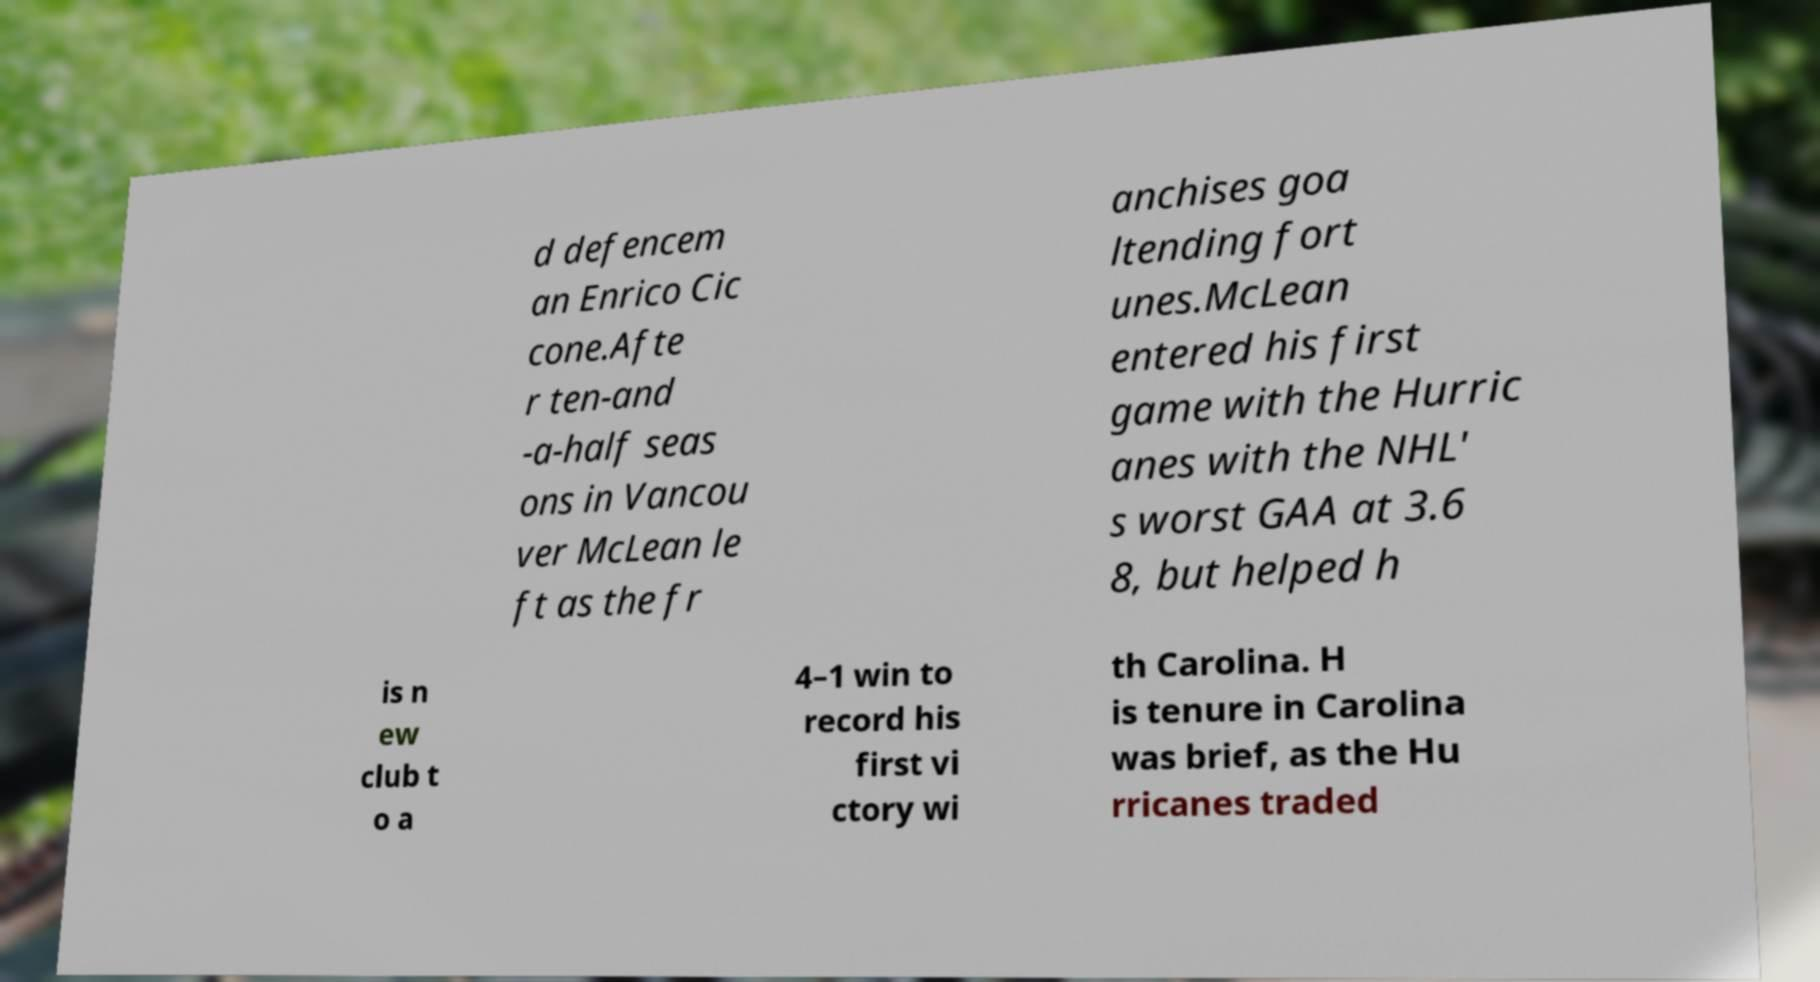What messages or text are displayed in this image? I need them in a readable, typed format. d defencem an Enrico Cic cone.Afte r ten-and -a-half seas ons in Vancou ver McLean le ft as the fr anchises goa ltending fort unes.McLean entered his first game with the Hurric anes with the NHL' s worst GAA at 3.6 8, but helped h is n ew club t o a 4–1 win to record his first vi ctory wi th Carolina. H is tenure in Carolina was brief, as the Hu rricanes traded 